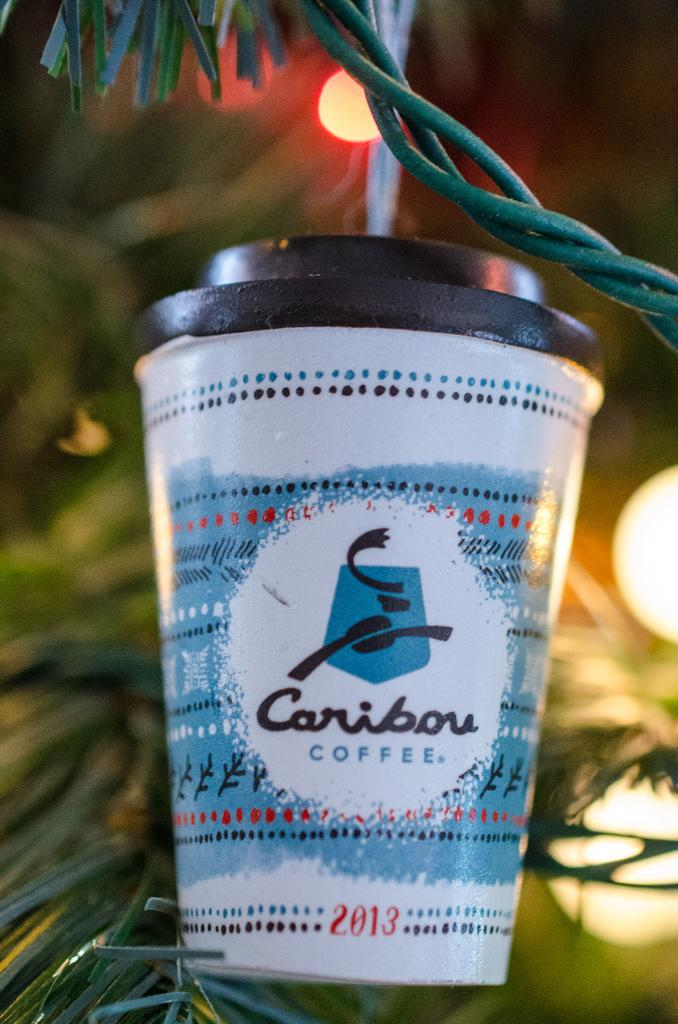<image>
Present a compact description of the photo's key features. A 2013 caribou coffee ornament hangs on the tree 